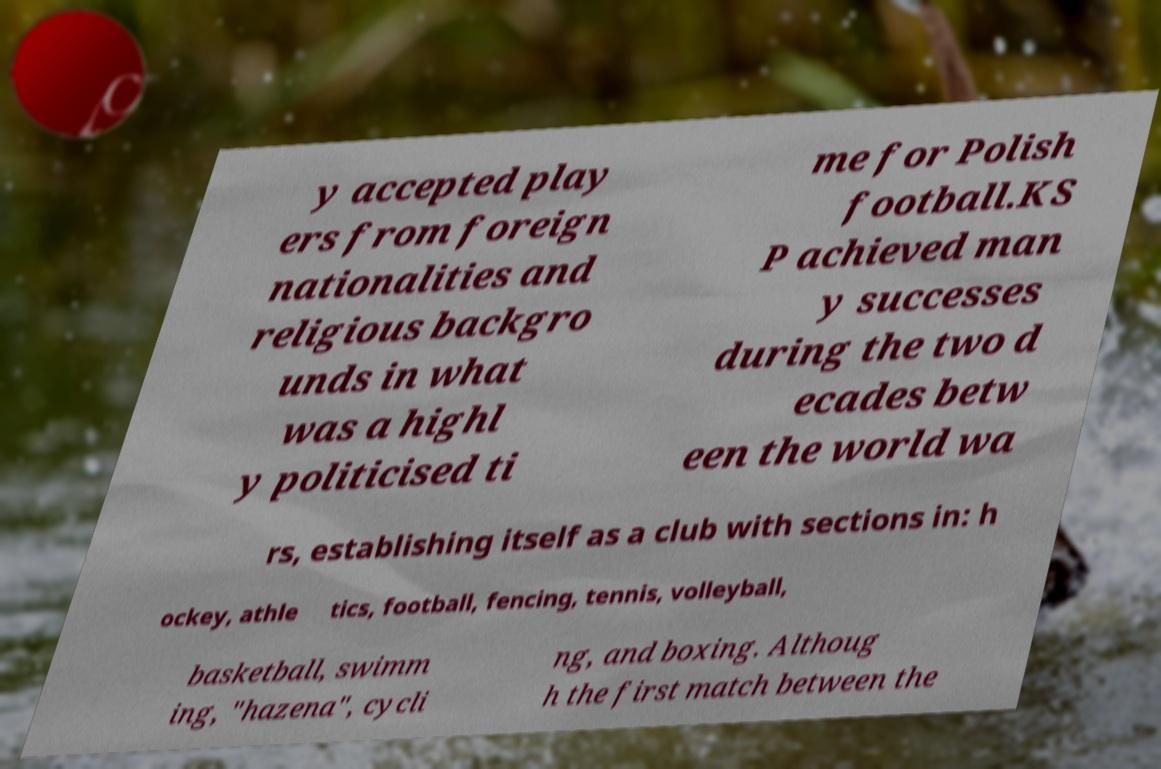Please identify and transcribe the text found in this image. y accepted play ers from foreign nationalities and religious backgro unds in what was a highl y politicised ti me for Polish football.KS P achieved man y successes during the two d ecades betw een the world wa rs, establishing itself as a club with sections in: h ockey, athle tics, football, fencing, tennis, volleyball, basketball, swimm ing, "hazena", cycli ng, and boxing. Althoug h the first match between the 